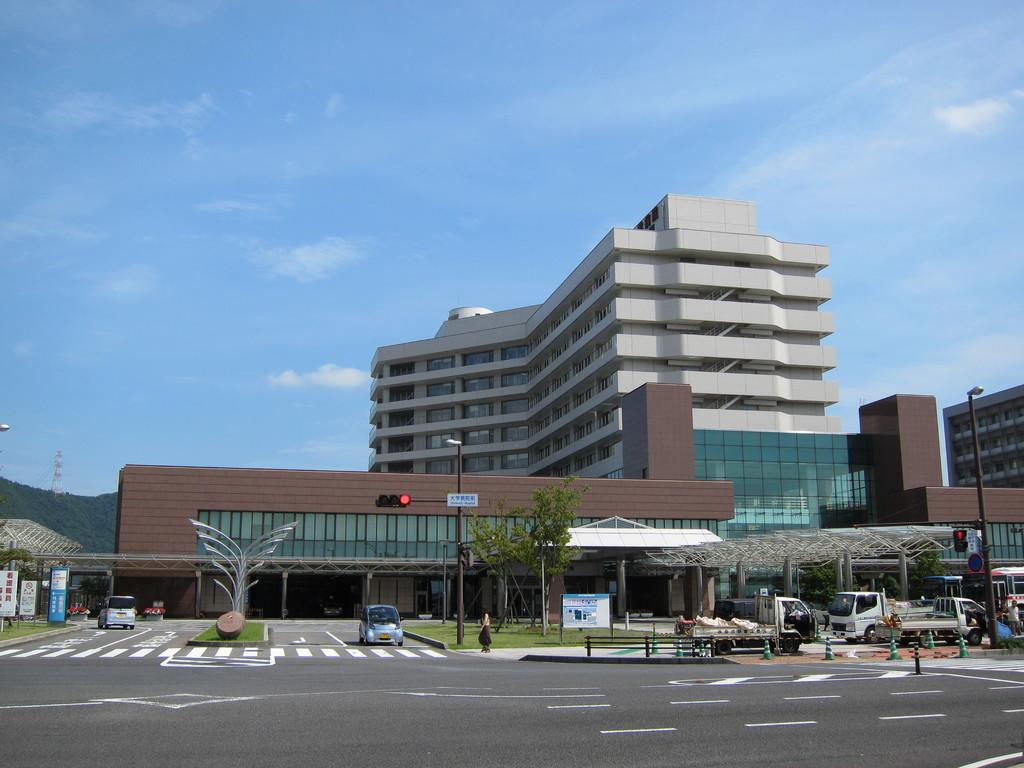What type of structures can be seen in the image? There are buildings in the image. What are the vertical objects in the image? There are poles in the image. What type of vegetation is present in the image? There are trees in the image. What type of transportation can be seen in the image? There are vehicles and cars in the image. What type of signage is present in the image? There are boards in the image. What type of surface is visible in the image? There is grass and a road in the image. What type of safety equipment is present in the image? There are traffic cones in the image. What can be seen in the background of the image? There is a mountain, a tower, and sky visible in the background of the image. How does the street learn to control the traffic in the image? There is no street present in the image, and streets do not have the ability to learn or control traffic. 